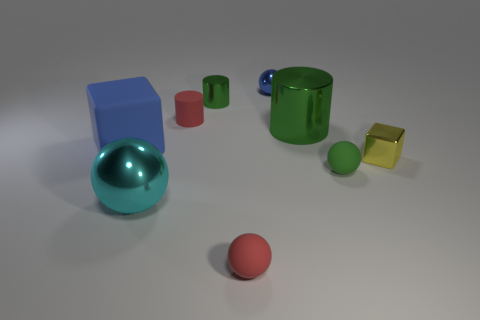Is the rubber block the same color as the tiny metal sphere?
Ensure brevity in your answer.  Yes. What number of other things are there of the same material as the small blue thing
Make the answer very short. 4. What is the shape of the big object that is behind the small shiny block and to the left of the large green thing?
Provide a short and direct response. Cube. Is the color of the tiny metal cylinder the same as the big object right of the tiny green metallic object?
Offer a terse response. Yes. Does the cube that is left of the yellow cube have the same size as the big cyan metal ball?
Offer a terse response. Yes. What material is the red thing that is the same shape as the big cyan object?
Provide a succinct answer. Rubber. Do the large green shiny object and the tiny blue metallic object have the same shape?
Ensure brevity in your answer.  No. There is a small red matte object that is behind the large metallic cylinder; what number of cyan metallic objects are to the left of it?
Keep it short and to the point. 1. There is a big green thing that is made of the same material as the yellow thing; what is its shape?
Offer a very short reply. Cylinder. How many yellow objects are small cubes or large rubber cubes?
Your answer should be compact. 1. 